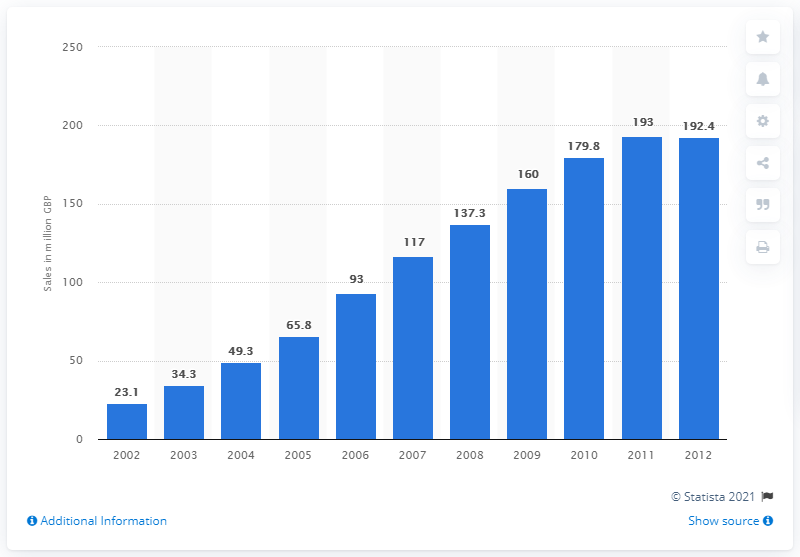Identify some key points in this picture. In 2011, the retail sales value of fairtrade coffee was 192.4 million dollars. 